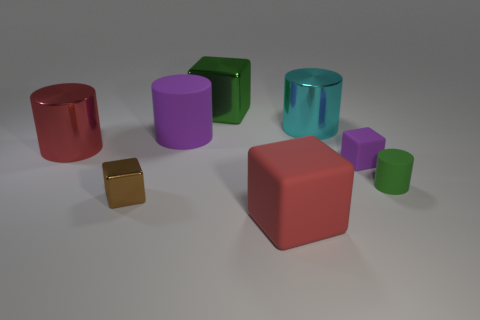Subtract all purple cubes. How many cubes are left? 3 Subtract all cyan cylinders. How many cylinders are left? 3 Add 1 small metal blocks. How many objects exist? 9 Subtract 4 cylinders. How many cylinders are left? 0 Add 8 purple cylinders. How many purple cylinders exist? 9 Subtract 1 red cubes. How many objects are left? 7 Subtract all green cylinders. Subtract all yellow cubes. How many cylinders are left? 3 Subtract all green balls. Subtract all large red blocks. How many objects are left? 7 Add 7 large metallic objects. How many large metallic objects are left? 10 